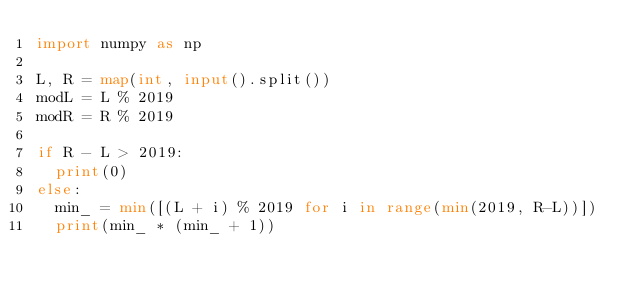<code> <loc_0><loc_0><loc_500><loc_500><_Python_>import numpy as np

L, R = map(int, input().split())
modL = L % 2019
modR = R % 2019

if R - L > 2019:
  print(0)
else:
	min_ = min([(L + i) % 2019 for i in range(min(2019, R-L))])
	print(min_ * (min_ + 1))</code> 